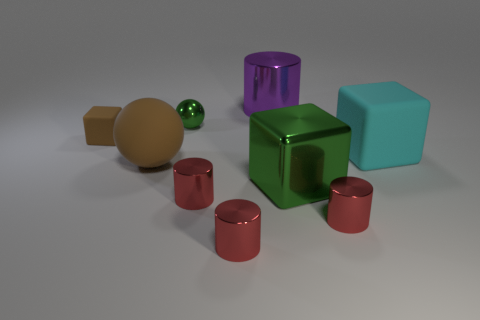Subtract all large cyan rubber cubes. How many cubes are left? 2 Add 1 rubber spheres. How many objects exist? 10 Subtract 1 cylinders. How many cylinders are left? 3 Subtract all red cylinders. How many cylinders are left? 1 Subtract all spheres. How many objects are left? 7 Subtract all blue balls. How many gray cubes are left? 0 Subtract all red objects. Subtract all large metal cylinders. How many objects are left? 5 Add 5 tiny cylinders. How many tiny cylinders are left? 8 Add 1 big brown objects. How many big brown objects exist? 2 Subtract 0 yellow cubes. How many objects are left? 9 